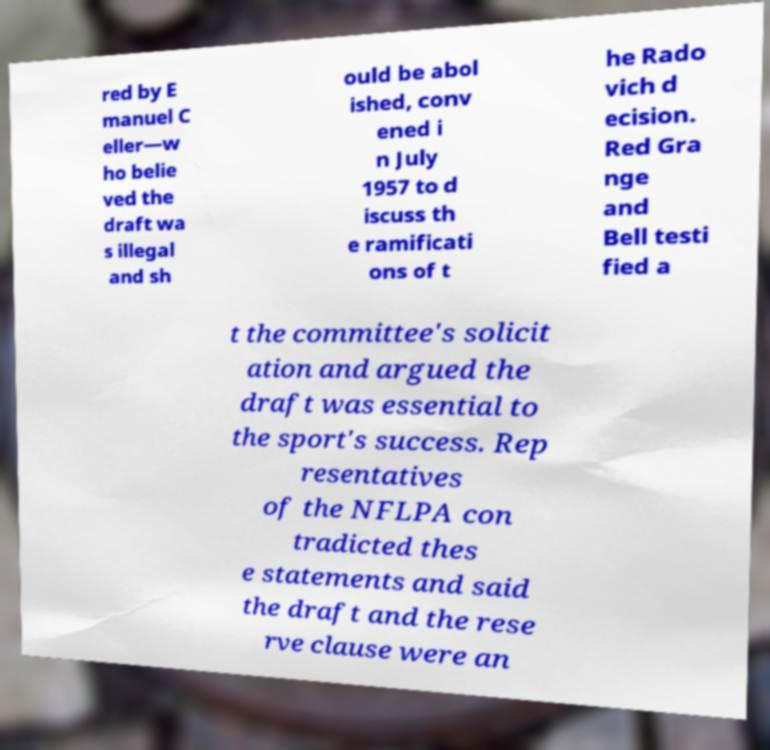There's text embedded in this image that I need extracted. Can you transcribe it verbatim? red by E manuel C eller—w ho belie ved the draft wa s illegal and sh ould be abol ished, conv ened i n July 1957 to d iscuss th e ramificati ons of t he Rado vich d ecision. Red Gra nge and Bell testi fied a t the committee's solicit ation and argued the draft was essential to the sport's success. Rep resentatives of the NFLPA con tradicted thes e statements and said the draft and the rese rve clause were an 